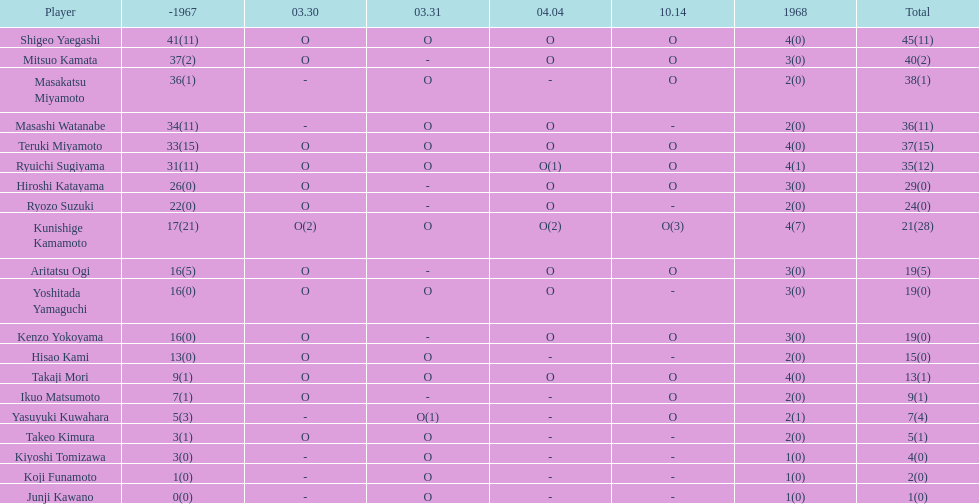How many additional overall appearances did shigeo yaegashi make compared to mitsuo kamata? 5. 